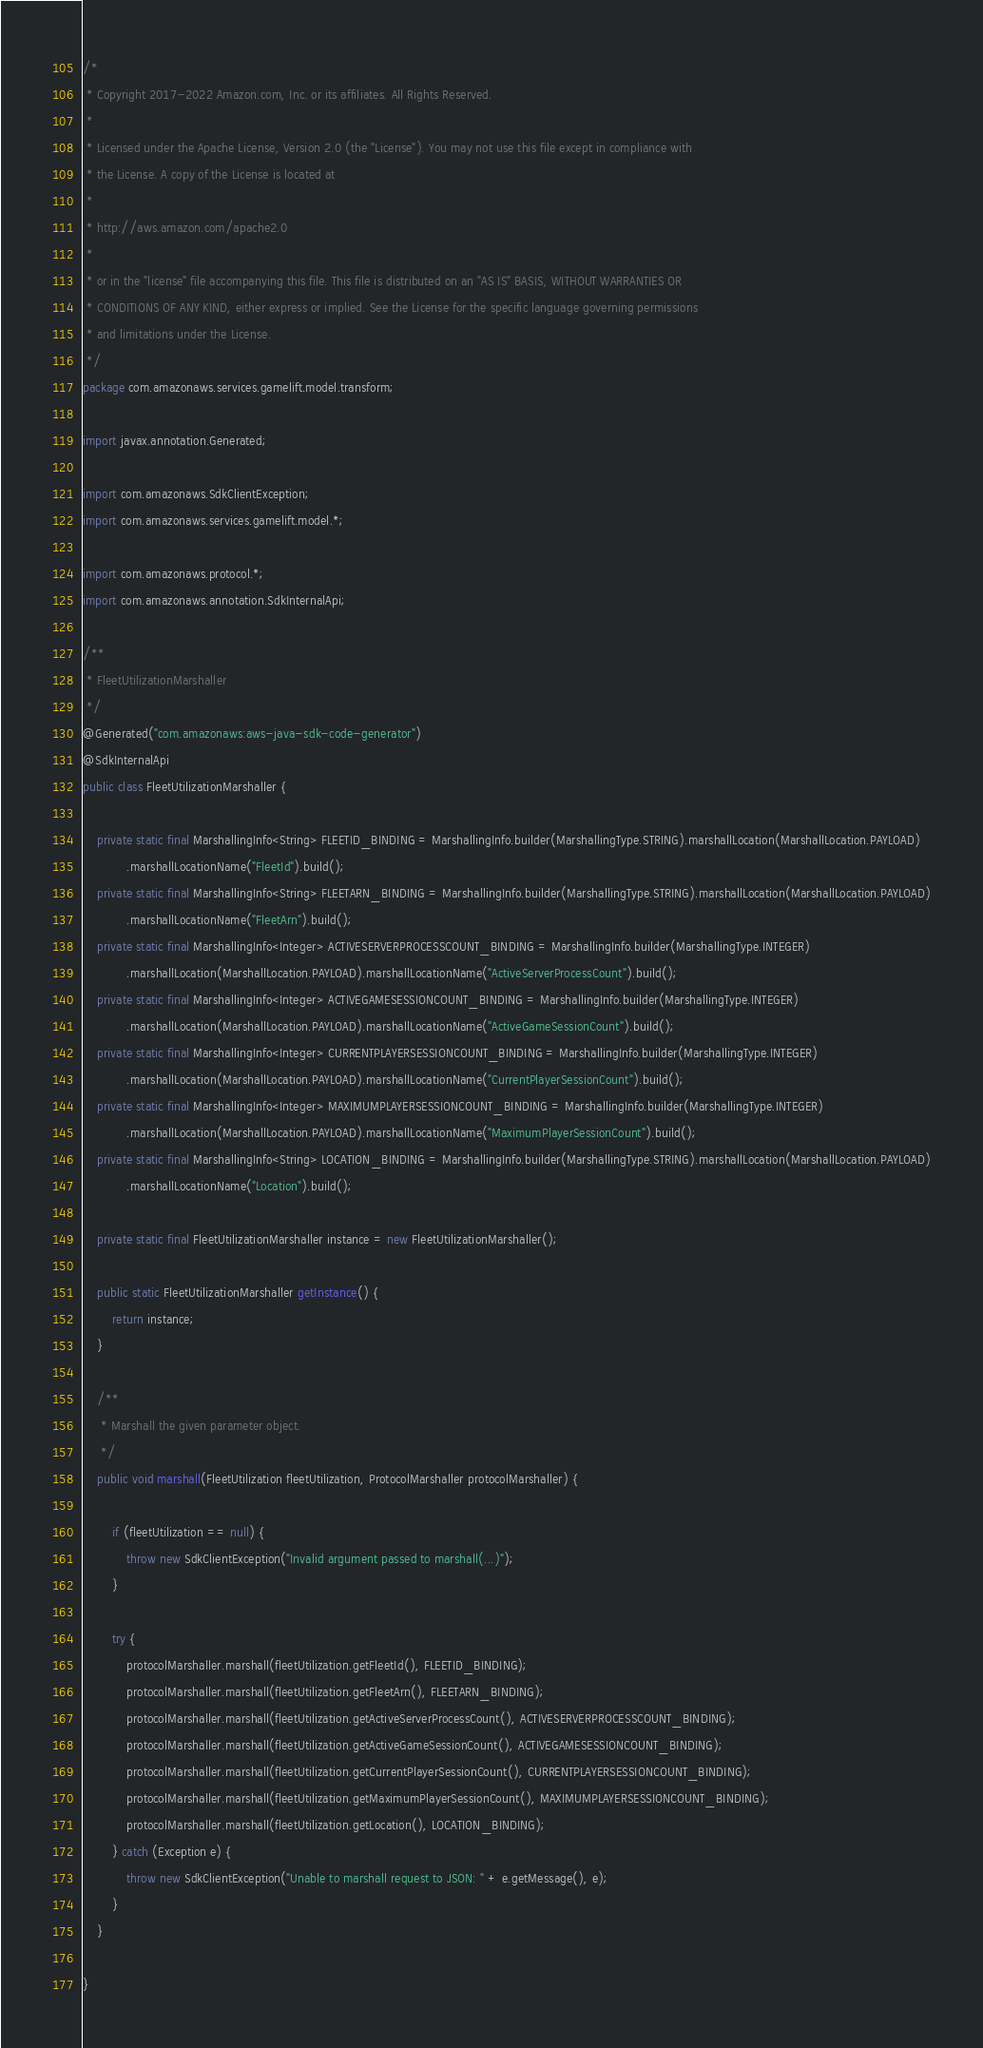<code> <loc_0><loc_0><loc_500><loc_500><_Java_>/*
 * Copyright 2017-2022 Amazon.com, Inc. or its affiliates. All Rights Reserved.
 * 
 * Licensed under the Apache License, Version 2.0 (the "License"). You may not use this file except in compliance with
 * the License. A copy of the License is located at
 * 
 * http://aws.amazon.com/apache2.0
 * 
 * or in the "license" file accompanying this file. This file is distributed on an "AS IS" BASIS, WITHOUT WARRANTIES OR
 * CONDITIONS OF ANY KIND, either express or implied. See the License for the specific language governing permissions
 * and limitations under the License.
 */
package com.amazonaws.services.gamelift.model.transform;

import javax.annotation.Generated;

import com.amazonaws.SdkClientException;
import com.amazonaws.services.gamelift.model.*;

import com.amazonaws.protocol.*;
import com.amazonaws.annotation.SdkInternalApi;

/**
 * FleetUtilizationMarshaller
 */
@Generated("com.amazonaws:aws-java-sdk-code-generator")
@SdkInternalApi
public class FleetUtilizationMarshaller {

    private static final MarshallingInfo<String> FLEETID_BINDING = MarshallingInfo.builder(MarshallingType.STRING).marshallLocation(MarshallLocation.PAYLOAD)
            .marshallLocationName("FleetId").build();
    private static final MarshallingInfo<String> FLEETARN_BINDING = MarshallingInfo.builder(MarshallingType.STRING).marshallLocation(MarshallLocation.PAYLOAD)
            .marshallLocationName("FleetArn").build();
    private static final MarshallingInfo<Integer> ACTIVESERVERPROCESSCOUNT_BINDING = MarshallingInfo.builder(MarshallingType.INTEGER)
            .marshallLocation(MarshallLocation.PAYLOAD).marshallLocationName("ActiveServerProcessCount").build();
    private static final MarshallingInfo<Integer> ACTIVEGAMESESSIONCOUNT_BINDING = MarshallingInfo.builder(MarshallingType.INTEGER)
            .marshallLocation(MarshallLocation.PAYLOAD).marshallLocationName("ActiveGameSessionCount").build();
    private static final MarshallingInfo<Integer> CURRENTPLAYERSESSIONCOUNT_BINDING = MarshallingInfo.builder(MarshallingType.INTEGER)
            .marshallLocation(MarshallLocation.PAYLOAD).marshallLocationName("CurrentPlayerSessionCount").build();
    private static final MarshallingInfo<Integer> MAXIMUMPLAYERSESSIONCOUNT_BINDING = MarshallingInfo.builder(MarshallingType.INTEGER)
            .marshallLocation(MarshallLocation.PAYLOAD).marshallLocationName("MaximumPlayerSessionCount").build();
    private static final MarshallingInfo<String> LOCATION_BINDING = MarshallingInfo.builder(MarshallingType.STRING).marshallLocation(MarshallLocation.PAYLOAD)
            .marshallLocationName("Location").build();

    private static final FleetUtilizationMarshaller instance = new FleetUtilizationMarshaller();

    public static FleetUtilizationMarshaller getInstance() {
        return instance;
    }

    /**
     * Marshall the given parameter object.
     */
    public void marshall(FleetUtilization fleetUtilization, ProtocolMarshaller protocolMarshaller) {

        if (fleetUtilization == null) {
            throw new SdkClientException("Invalid argument passed to marshall(...)");
        }

        try {
            protocolMarshaller.marshall(fleetUtilization.getFleetId(), FLEETID_BINDING);
            protocolMarshaller.marshall(fleetUtilization.getFleetArn(), FLEETARN_BINDING);
            protocolMarshaller.marshall(fleetUtilization.getActiveServerProcessCount(), ACTIVESERVERPROCESSCOUNT_BINDING);
            protocolMarshaller.marshall(fleetUtilization.getActiveGameSessionCount(), ACTIVEGAMESESSIONCOUNT_BINDING);
            protocolMarshaller.marshall(fleetUtilization.getCurrentPlayerSessionCount(), CURRENTPLAYERSESSIONCOUNT_BINDING);
            protocolMarshaller.marshall(fleetUtilization.getMaximumPlayerSessionCount(), MAXIMUMPLAYERSESSIONCOUNT_BINDING);
            protocolMarshaller.marshall(fleetUtilization.getLocation(), LOCATION_BINDING);
        } catch (Exception e) {
            throw new SdkClientException("Unable to marshall request to JSON: " + e.getMessage(), e);
        }
    }

}
</code> 